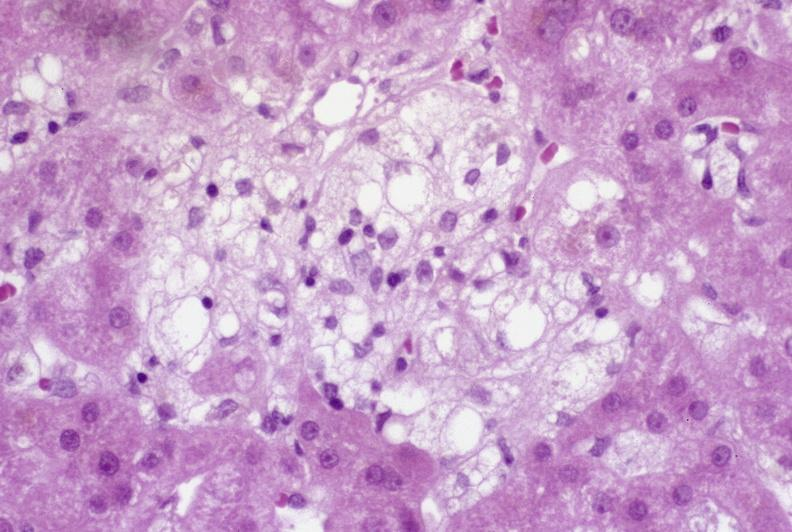s hepatobiliary present?
Answer the question using a single word or phrase. Yes 